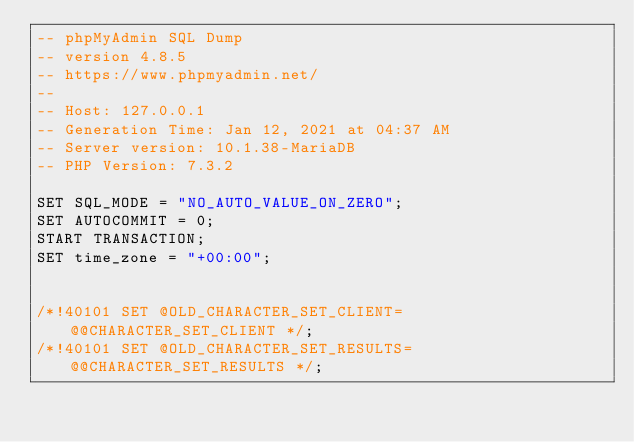<code> <loc_0><loc_0><loc_500><loc_500><_SQL_>-- phpMyAdmin SQL Dump
-- version 4.8.5
-- https://www.phpmyadmin.net/
--
-- Host: 127.0.0.1
-- Generation Time: Jan 12, 2021 at 04:37 AM
-- Server version: 10.1.38-MariaDB
-- PHP Version: 7.3.2

SET SQL_MODE = "NO_AUTO_VALUE_ON_ZERO";
SET AUTOCOMMIT = 0;
START TRANSACTION;
SET time_zone = "+00:00";


/*!40101 SET @OLD_CHARACTER_SET_CLIENT=@@CHARACTER_SET_CLIENT */;
/*!40101 SET @OLD_CHARACTER_SET_RESULTS=@@CHARACTER_SET_RESULTS */;</code> 